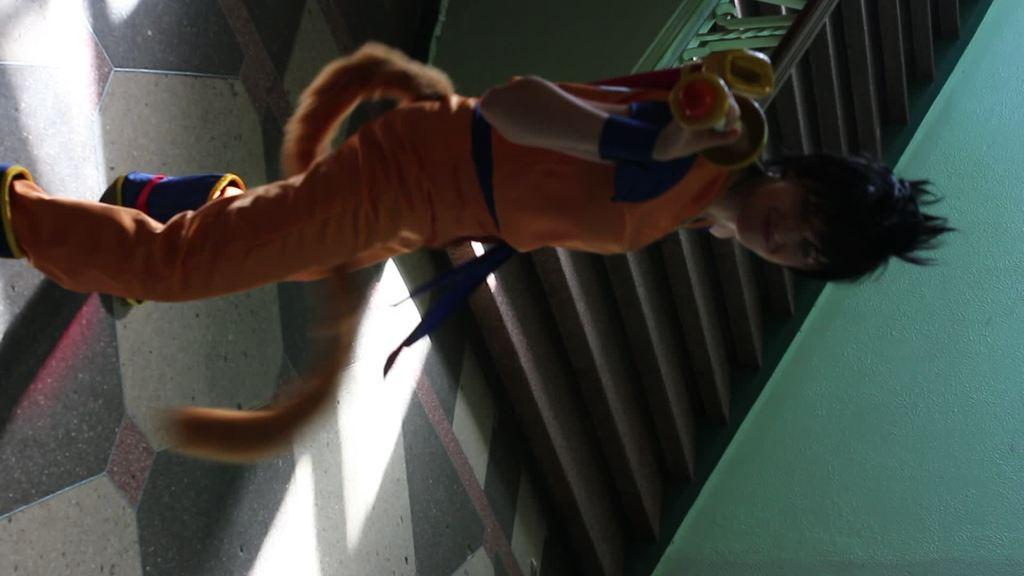Who is present in the image? There is a woman in the image. What is the woman wearing? The woman is wearing a costume. Where is the woman standing in the image? The woman is standing on the floor. What can be seen in the background of the image? There are stairs and a wall in the background of the image. What type of silk is the woman reading in the image? There is no silk or reading activity present in the image. 